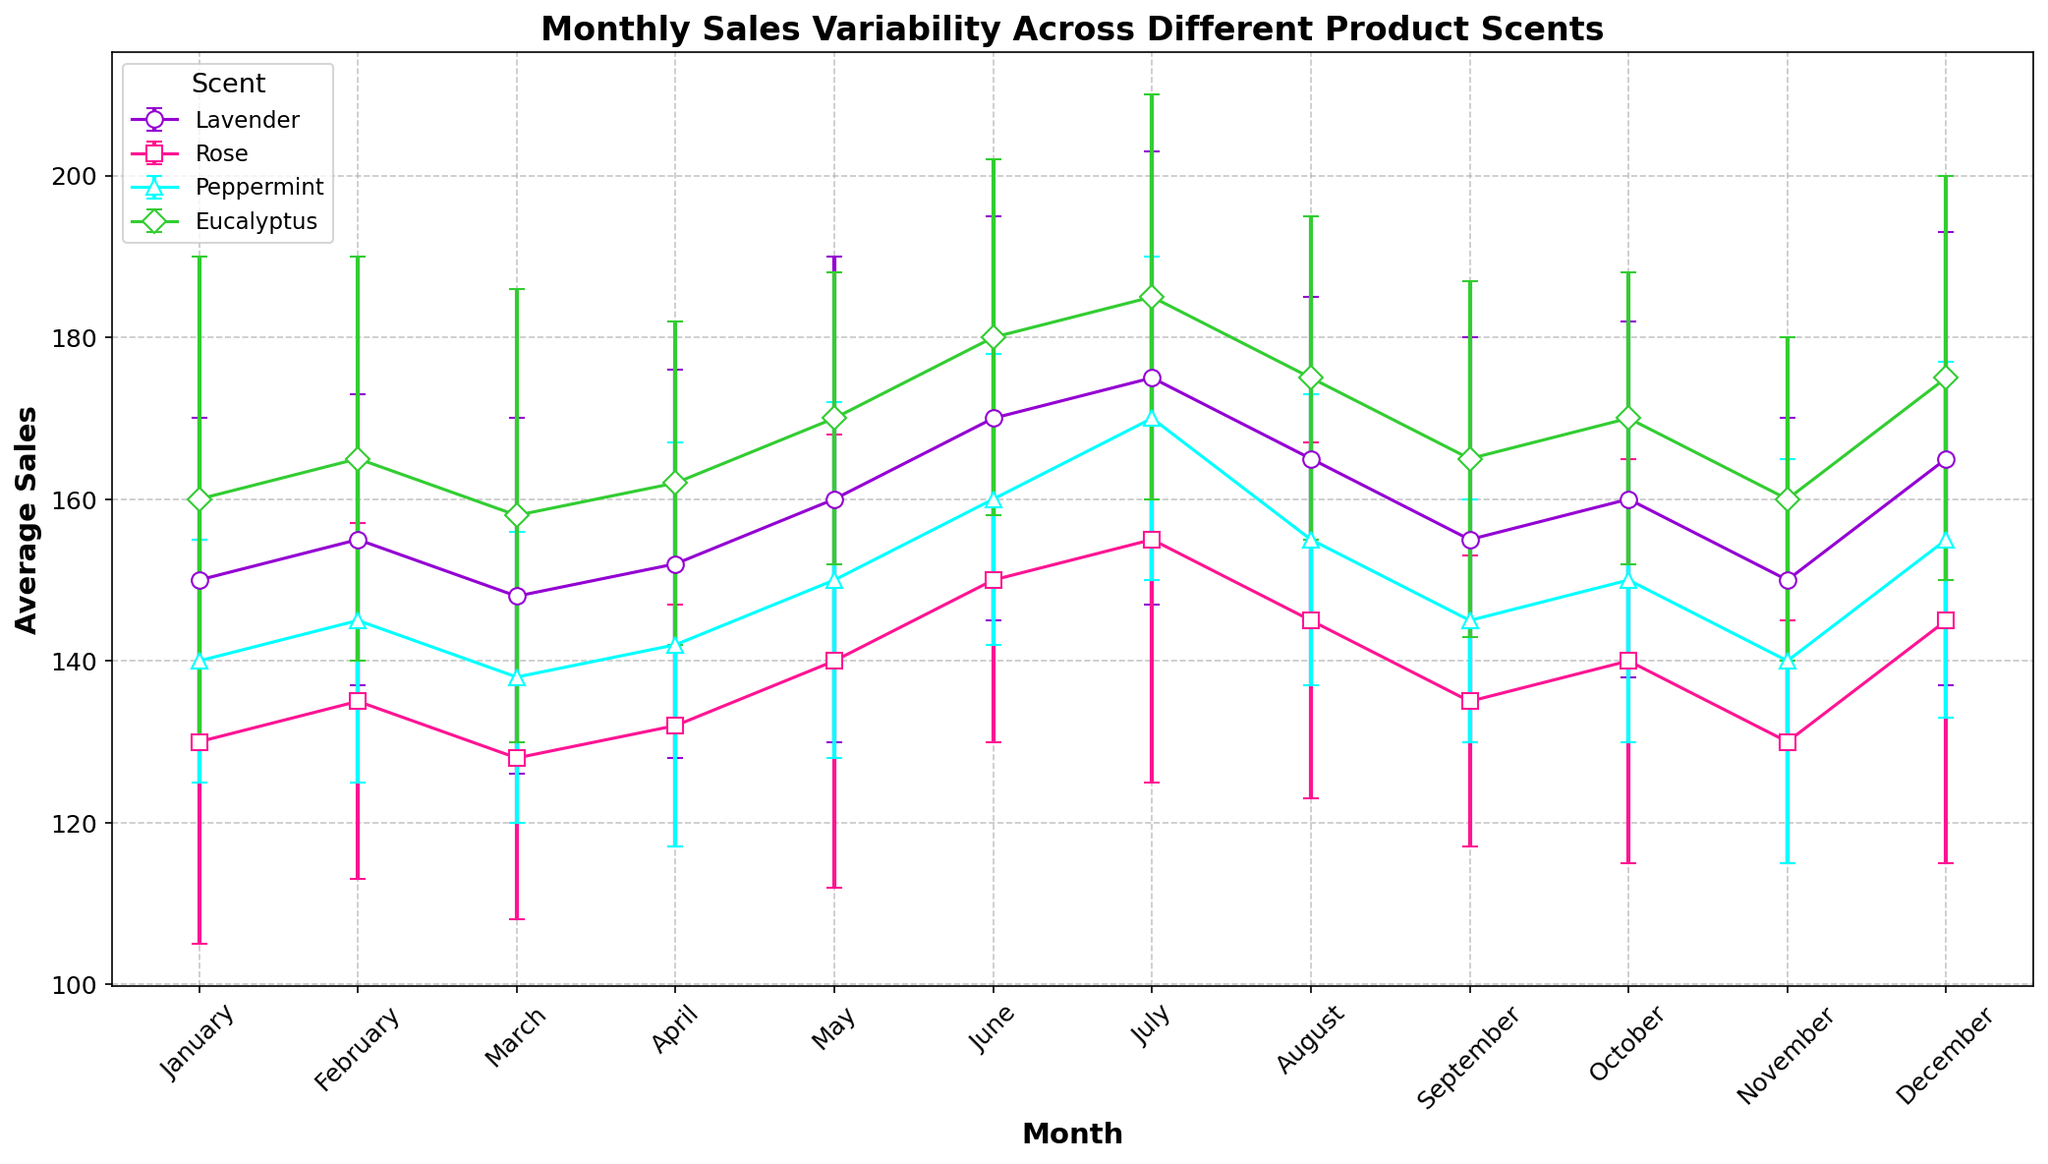Which scent had the highest average sales in July? In July, the Eucalyptus scent reached an average sales of 185, which is the highest among all scents for that month.
Answer: Eucalyptus What was the range of average sales for Peppermint throughout the year? The range is calculated by subtracting the minimum average sales from the maximum. The maximum for Peppermint is 170 in July, and the minimum is 138 in March, resulting in a range of 170 - 138 = 32.
Answer: 32 Compare the standard deviation of Lavender sales in May versus July. Which month had more variability? In May, the standard deviation for Lavender was 30, and in July, it was 28. Since 30 is greater than 28, May had more variability.
Answer: May Which month had the lowest average sales for Rose? By scanning the graph, we can see that January and November both had the lowest average sales for Rose, which is 130.
Answer: January and November During which month did Eucalyptus sales have the lowest variability and what was the standard deviation? To find the month with the lowest variability for Eucalyptus, we look at the month with the smallest standard deviation. April had the lowest with a standard deviation of 20.
Answer: April, 20 If you compare the average sales of Lavender and Rose in August, which one is higher and by how much? Lavender sales were 165 while Rose sales were 145 in August. The difference is 165 - 145 = 20.
Answer: Lavender, 20 What is the trend in the average sales of Lavender from June to August? The trend shows a decrease from June to August. June had 170, July had 175, and August had 165.
Answer: Decreasing How do the average sales of Peppermint in October compare to its average sales in December? The average sales of Peppermint were 150 in October and increased to 155 in December, showing a slight increase of 5 units.
Answer: Increased by 5 units Which scent showed the highest average sales in January and what were the sales? Eucalyptus had the highest average sales in January, with an average of 160.
Answer: Eucalyptus, 160 Identify the month in which Rose had the maximum sales and state the amount. The highest average sales for Rose were in July, with 155 units sold.
Answer: July, 155 